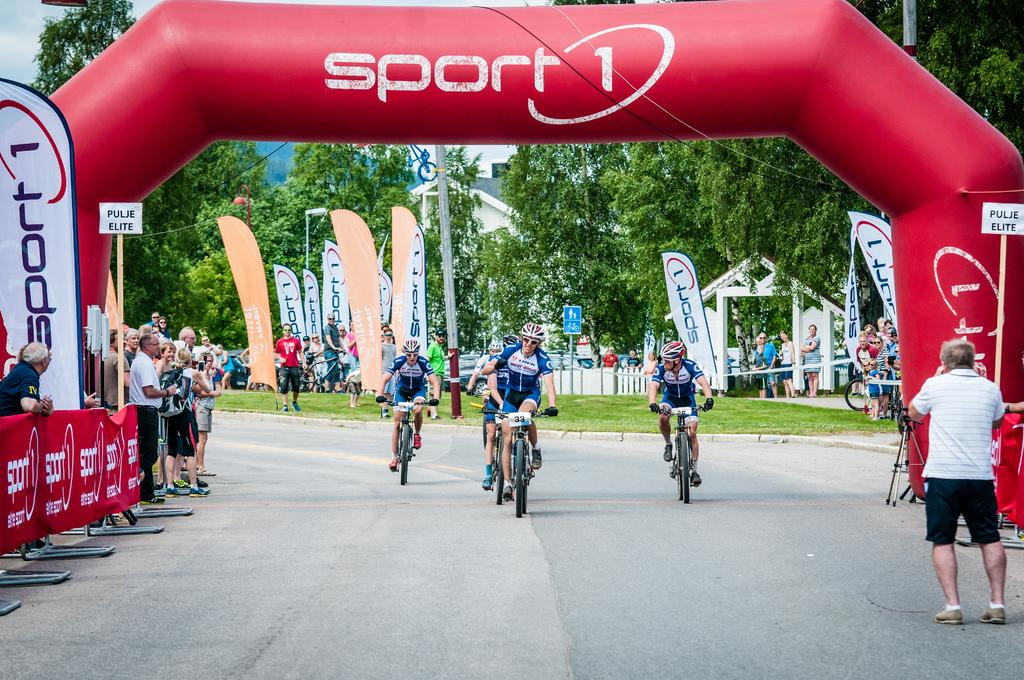What are the people in the image doing? The people in the image are riding bicycles. Where are the bicycles located? The bicycles are on a road. What can be seen above the road in the image? There is an arch in the image. What type of objects are present in the image, besides the bicycles and people? There are boards, trees, and buildings in the image. Can you tell me how many branches are on the horse in the image? There is no horse present in the image, so there are no branches to count. 